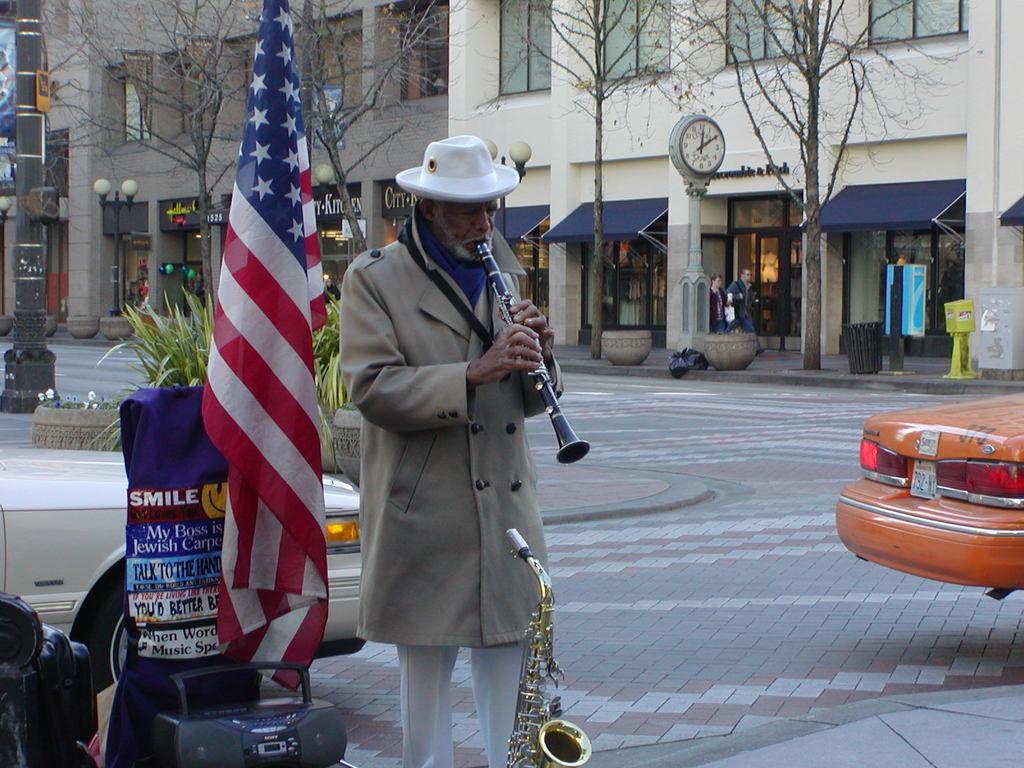In one or two sentences, can you explain what this image depicts? In this image, we can see a person standing in front of the flag and playing a musical instrument. There is a trumpet and radio at the bottom of the image. There is a pole on the left side of the image. There is a car in the bottom left and in the bottom right of the image. There is a clock in the middle of the image. In the background of the image, there are some trees and buildings. 